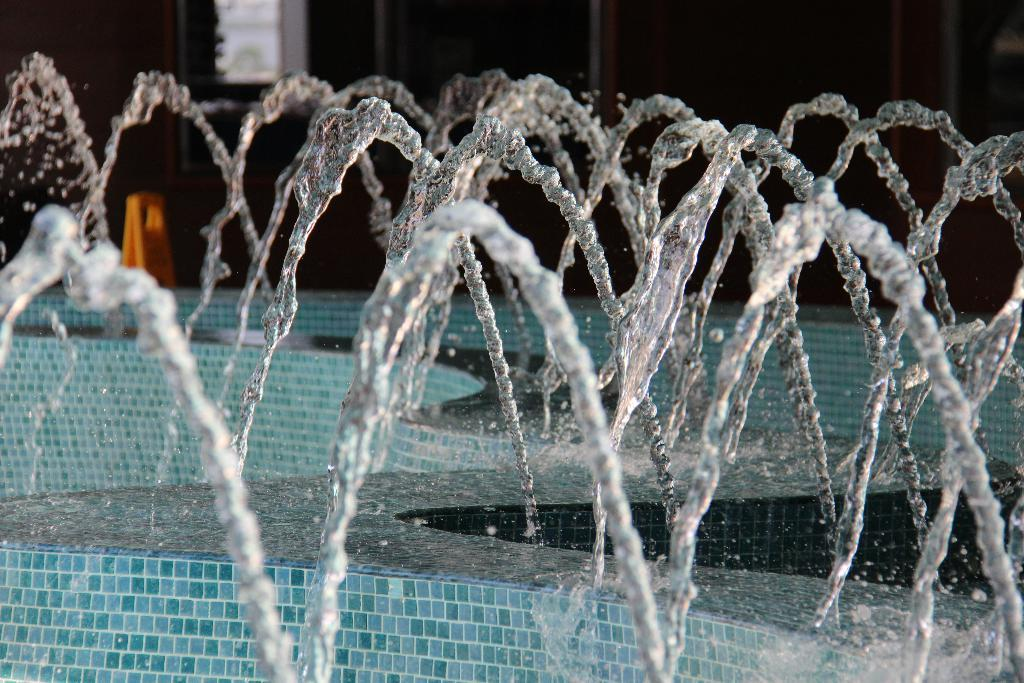What is the main feature in the image? There is a water fountain in the image. What type of surface is visible near the water fountain? There is a tile surface visible in the image. Can you describe the color of any objects in the background? There is an orange color object in the background of the image. How many dogs are sitting on the oatmeal in the image? There are no dogs or oatmeal present in the image. 